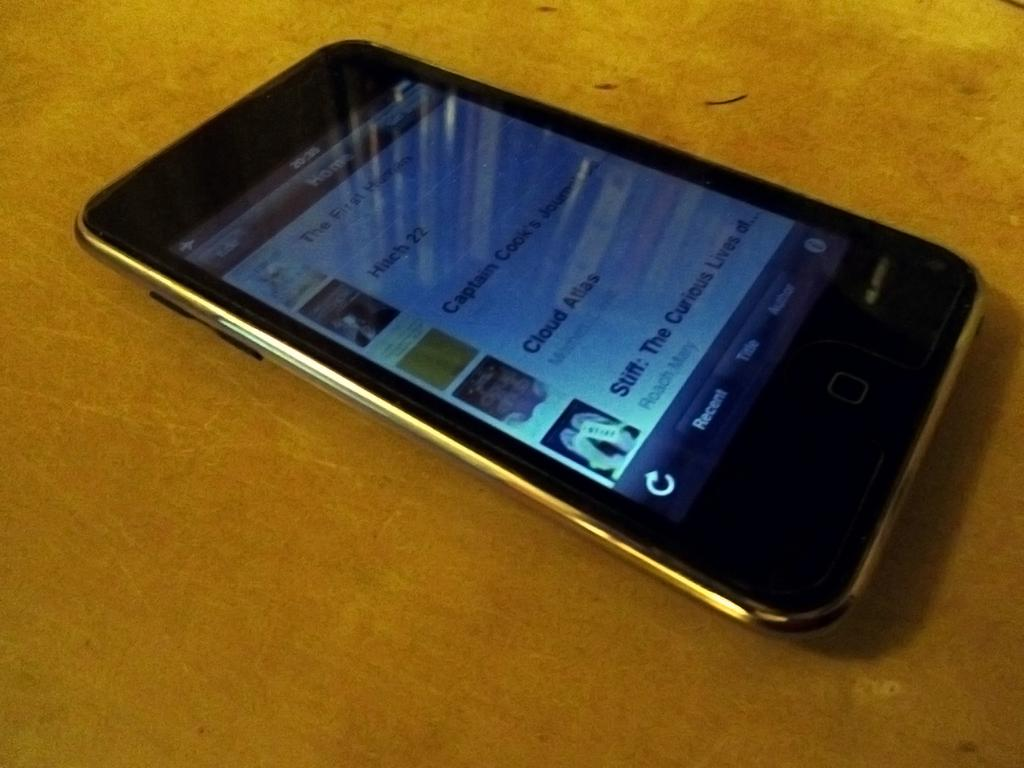What can be seen hanging in the image? There is a mobile in the image. What is the mobile placed on? The mobile is placed on an object. What type of behavior does the thumb exhibit in the image? There is no thumb present in the image, so it is not possible to determine its behavior. 